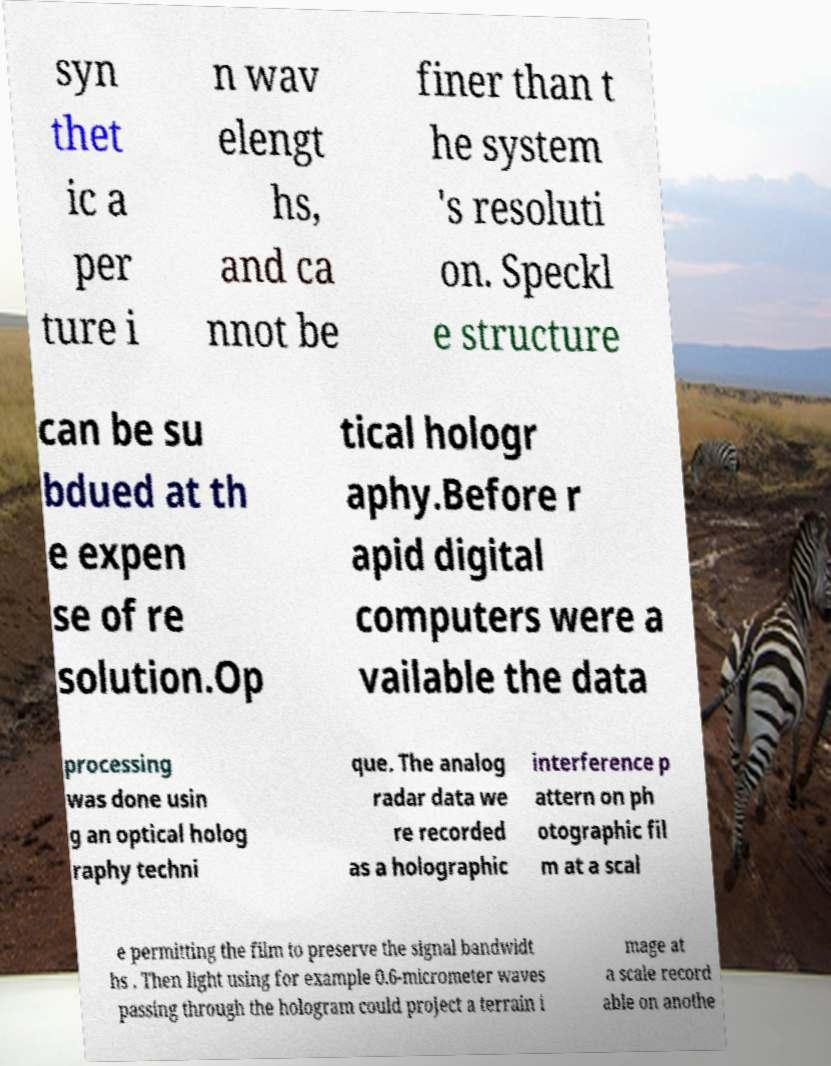What messages or text are displayed in this image? I need them in a readable, typed format. syn thet ic a per ture i n wav elengt hs, and ca nnot be finer than t he system 's resoluti on. Speckl e structure can be su bdued at th e expen se of re solution.Op tical hologr aphy.Before r apid digital computers were a vailable the data processing was done usin g an optical holog raphy techni que. The analog radar data we re recorded as a holographic interference p attern on ph otographic fil m at a scal e permitting the film to preserve the signal bandwidt hs . Then light using for example 0.6-micrometer waves passing through the hologram could project a terrain i mage at a scale record able on anothe 